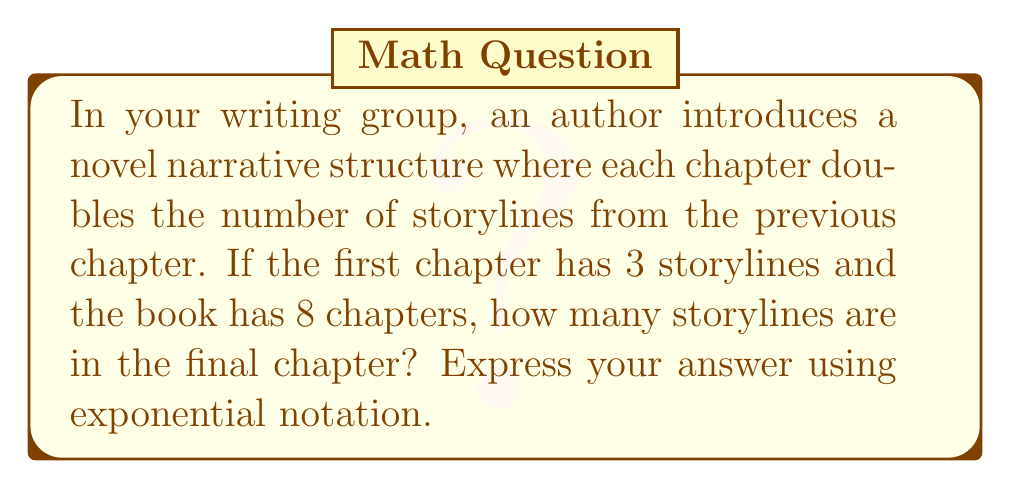What is the answer to this math problem? Let's approach this step-by-step:

1) We start with 3 storylines in the first chapter.
2) Each subsequent chapter doubles the number of storylines.
3) This doubling occurs 7 times (from chapter 1 to chapter 8).

We can express this mathematically as:

$$ 3 \cdot 2^7 $$

Where:
- 3 is the initial number of storylines
- 2 is the factor by which the storylines increase each chapter
- 7 is the number of times this doubling occurs (8 chapters - 1)

Let's calculate:

$$ 3 \cdot 2^7 = 3 \cdot 128 = 384 $$

Therefore, the final chapter contains 384 storylines.

This can be written in exponential notation as:

$$ 3 \cdot 2^7 $$
Answer: $3 \cdot 2^7$ 